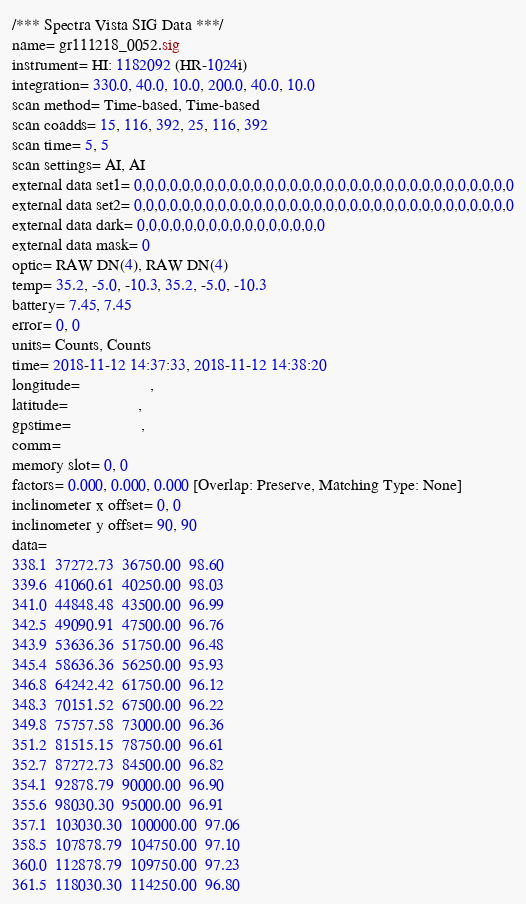<code> <loc_0><loc_0><loc_500><loc_500><_SML_>/*** Spectra Vista SIG Data ***/
name= gr111218_0052.sig
instrument= HI: 1182092 (HR-1024i)
integration= 330.0, 40.0, 10.0, 200.0, 40.0, 10.0
scan method= Time-based, Time-based
scan coadds= 15, 116, 392, 25, 116, 392
scan time= 5, 5
scan settings= AI, AI
external data set1= 0,0,0,0,0,0,0,0,0,0,0,0,0,0,0,0,0,0,0,0,0,0,0,0,0,0,0,0,0,0,0,0
external data set2= 0,0,0,0,0,0,0,0,0,0,0,0,0,0,0,0,0,0,0,0,0,0,0,0,0,0,0,0,0,0,0,0
external data dark= 0,0,0,0,0,0,0,0,0,0,0,0,0,0,0,0
external data mask= 0
optic= RAW DN(4), RAW DN(4)
temp= 35.2, -5.0, -10.3, 35.2, -5.0, -10.3
battery= 7.45, 7.45
error= 0, 0
units= Counts, Counts
time= 2018-11-12 14:37:33, 2018-11-12 14:38:20
longitude=                 ,                 
latitude=                 ,                 
gpstime=                 ,                 
comm= 
memory slot= 0, 0
factors= 0.000, 0.000, 0.000 [Overlap: Preserve, Matching Type: None]
inclinometer x offset= 0, 0
inclinometer y offset= 90, 90
data= 
338.1  37272.73  36750.00  98.60
339.6  41060.61  40250.00  98.03
341.0  44848.48  43500.00  96.99
342.5  49090.91  47500.00  96.76
343.9  53636.36  51750.00  96.48
345.4  58636.36  56250.00  95.93
346.8  64242.42  61750.00  96.12
348.3  70151.52  67500.00  96.22
349.8  75757.58  73000.00  96.36
351.2  81515.15  78750.00  96.61
352.7  87272.73  84500.00  96.82
354.1  92878.79  90000.00  96.90
355.6  98030.30  95000.00  96.91
357.1  103030.30  100000.00  97.06
358.5  107878.79  104750.00  97.10
360.0  112878.79  109750.00  97.23
361.5  118030.30  114250.00  96.80</code> 